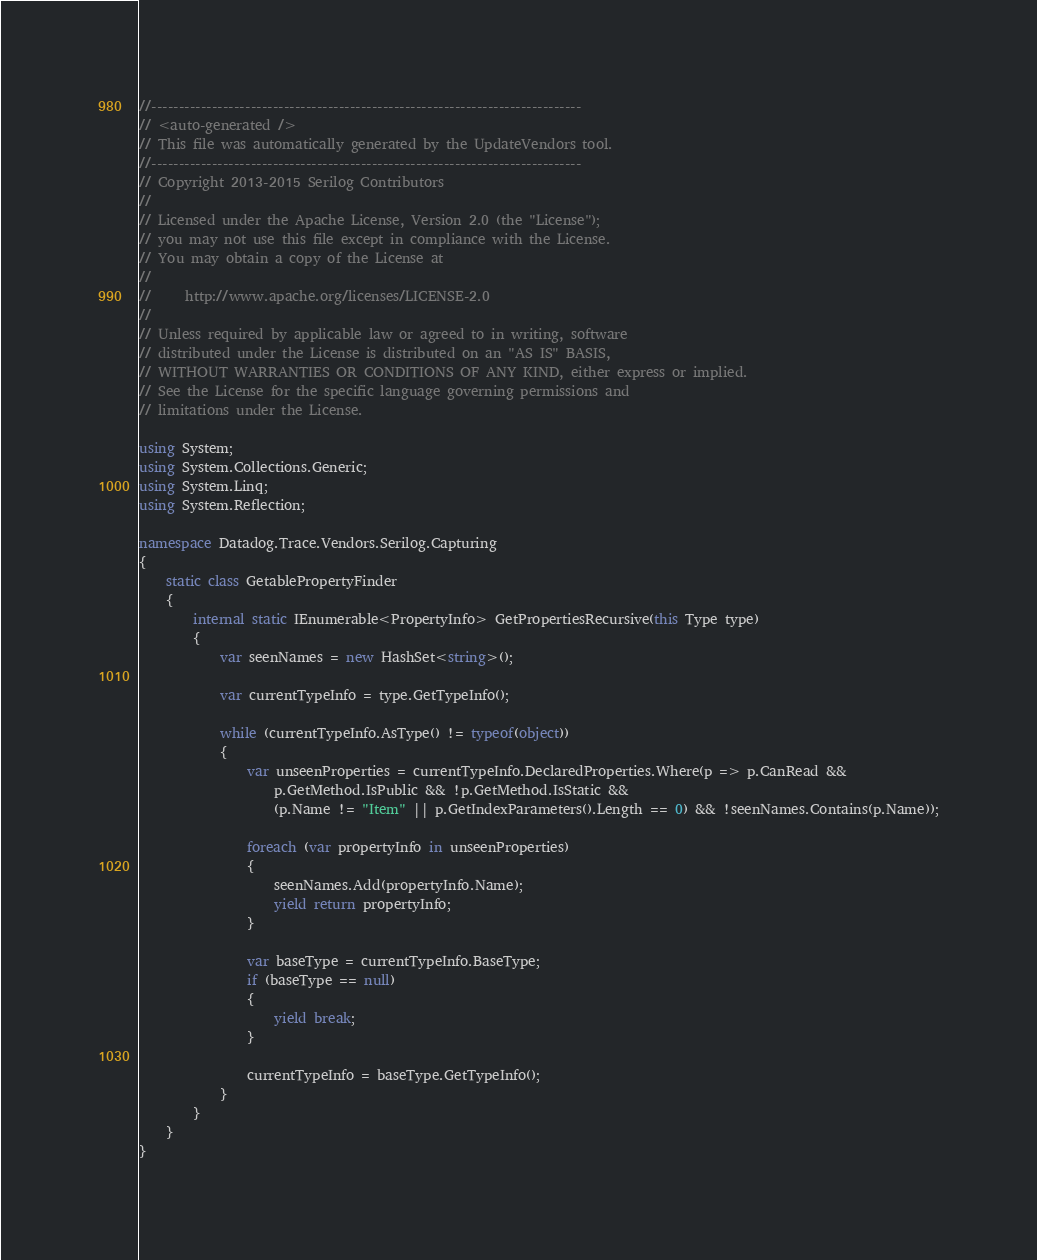<code> <loc_0><loc_0><loc_500><loc_500><_C#_>//------------------------------------------------------------------------------
// <auto-generated />
// This file was automatically generated by the UpdateVendors tool.
//------------------------------------------------------------------------------
// Copyright 2013-2015 Serilog Contributors
//
// Licensed under the Apache License, Version 2.0 (the "License");
// you may not use this file except in compliance with the License.
// You may obtain a copy of the License at
//
//     http://www.apache.org/licenses/LICENSE-2.0
//
// Unless required by applicable law or agreed to in writing, software
// distributed under the License is distributed on an "AS IS" BASIS,
// WITHOUT WARRANTIES OR CONDITIONS OF ANY KIND, either express or implied.
// See the License for the specific language governing permissions and
// limitations under the License.

using System;
using System.Collections.Generic;
using System.Linq;
using System.Reflection;

namespace Datadog.Trace.Vendors.Serilog.Capturing
{
    static class GetablePropertyFinder
    {
        internal static IEnumerable<PropertyInfo> GetPropertiesRecursive(this Type type)
        {
            var seenNames = new HashSet<string>();

            var currentTypeInfo = type.GetTypeInfo();

            while (currentTypeInfo.AsType() != typeof(object))
            {
                var unseenProperties = currentTypeInfo.DeclaredProperties.Where(p => p.CanRead &&
                    p.GetMethod.IsPublic && !p.GetMethod.IsStatic &&
                    (p.Name != "Item" || p.GetIndexParameters().Length == 0) && !seenNames.Contains(p.Name));

                foreach (var propertyInfo in unseenProperties)
                {
                    seenNames.Add(propertyInfo.Name);
                    yield return propertyInfo;
                }

                var baseType = currentTypeInfo.BaseType;
                if (baseType == null)
                {
                    yield break;
                }

                currentTypeInfo = baseType.GetTypeInfo();
            }
        }
    }
}
</code> 